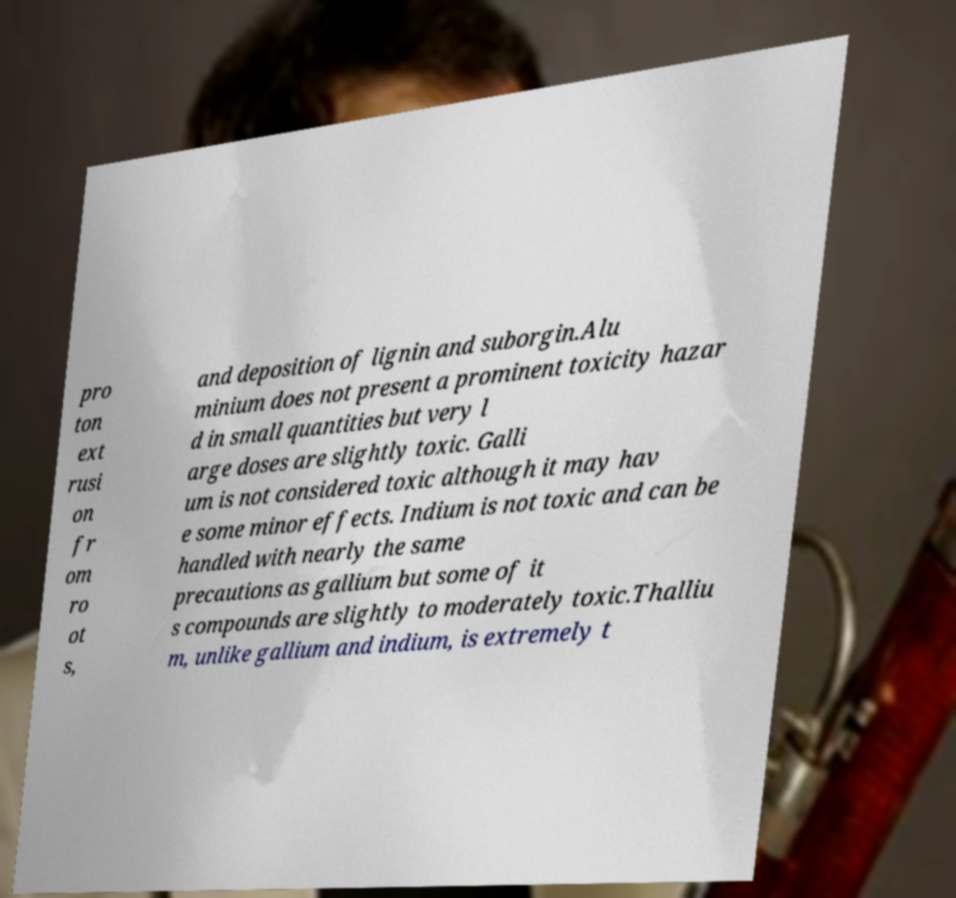There's text embedded in this image that I need extracted. Can you transcribe it verbatim? pro ton ext rusi on fr om ro ot s, and deposition of lignin and suborgin.Alu minium does not present a prominent toxicity hazar d in small quantities but very l arge doses are slightly toxic. Galli um is not considered toxic although it may hav e some minor effects. Indium is not toxic and can be handled with nearly the same precautions as gallium but some of it s compounds are slightly to moderately toxic.Thalliu m, unlike gallium and indium, is extremely t 